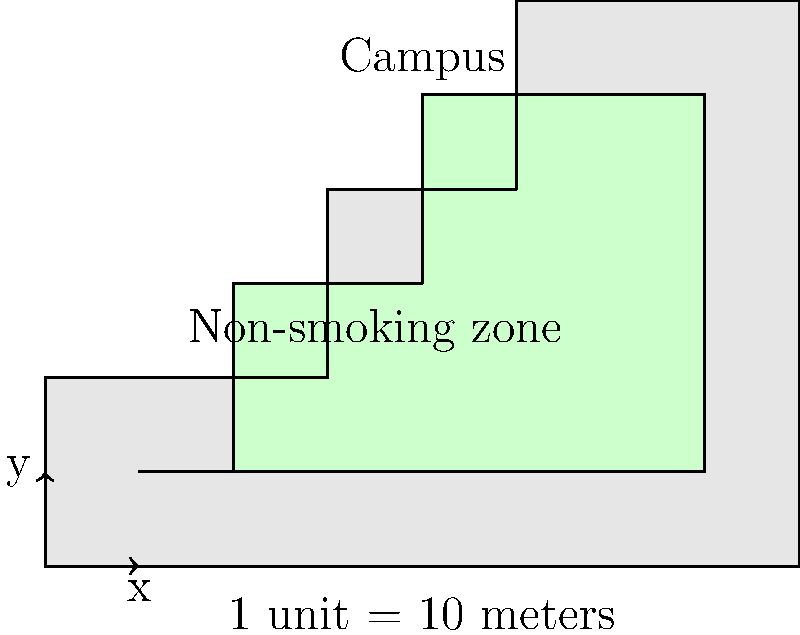A university campus has implemented a non-smoking policy in certain areas. The map above shows the campus boundary and the designated non-smoking zone with irregular boundaries. Given that 1 unit on the map represents 10 meters, calculate the perimeter of the non-smoking zone in meters. To calculate the perimeter of the non-smoking zone, we need to sum up the lengths of all sides:

1. Identify the coordinates of the non-smoking zone:
   (1,1), (7,1), (7,5), (4,5), (4,3), (2,3), (2,1)

2. Calculate the lengths of each side:
   a) (1,1) to (7,1): $\sqrt{(7-1)^2 + (1-1)^2} = 6$ units
   b) (7,1) to (7,5): $\sqrt{(7-7)^2 + (5-1)^2} = 4$ units
   c) (7,5) to (4,5): $\sqrt{(4-7)^2 + (5-5)^2} = 3$ units
   d) (4,5) to (4,3): $\sqrt{(4-4)^2 + (3-5)^2} = 2$ units
   e) (4,3) to (2,3): $\sqrt{(2-4)^2 + (3-3)^2} = 2$ units
   f) (2,3) to (2,1): $\sqrt{(2-2)^2 + (1-3)^2} = 2$ units
   g) (2,1) to (1,1): $\sqrt{(1-2)^2 + (1-1)^2} = 1$ unit

3. Sum up all the lengths:
   Total length = 6 + 4 + 3 + 2 + 2 + 2 + 1 = 20 units

4. Convert units to meters:
   20 units × 10 meters/unit = 200 meters

Therefore, the perimeter of the non-smoking zone is 200 meters.
Answer: 200 meters 